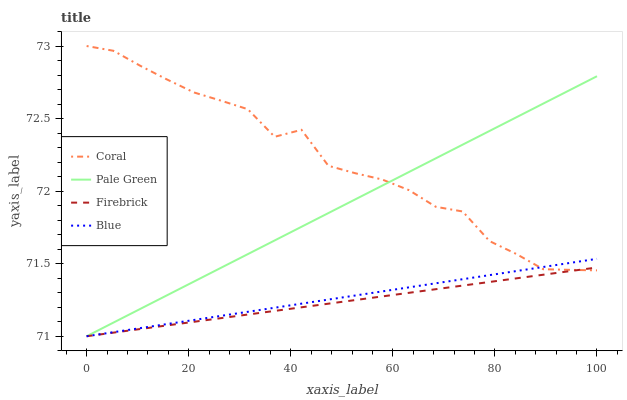Does Firebrick have the minimum area under the curve?
Answer yes or no. Yes. Does Coral have the maximum area under the curve?
Answer yes or no. Yes. Does Pale Green have the minimum area under the curve?
Answer yes or no. No. Does Pale Green have the maximum area under the curve?
Answer yes or no. No. Is Firebrick the smoothest?
Answer yes or no. Yes. Is Coral the roughest?
Answer yes or no. Yes. Is Pale Green the smoothest?
Answer yes or no. No. Is Pale Green the roughest?
Answer yes or no. No. Does Blue have the lowest value?
Answer yes or no. Yes. Does Coral have the lowest value?
Answer yes or no. No. Does Coral have the highest value?
Answer yes or no. Yes. Does Pale Green have the highest value?
Answer yes or no. No. Does Pale Green intersect Coral?
Answer yes or no. Yes. Is Pale Green less than Coral?
Answer yes or no. No. Is Pale Green greater than Coral?
Answer yes or no. No. 